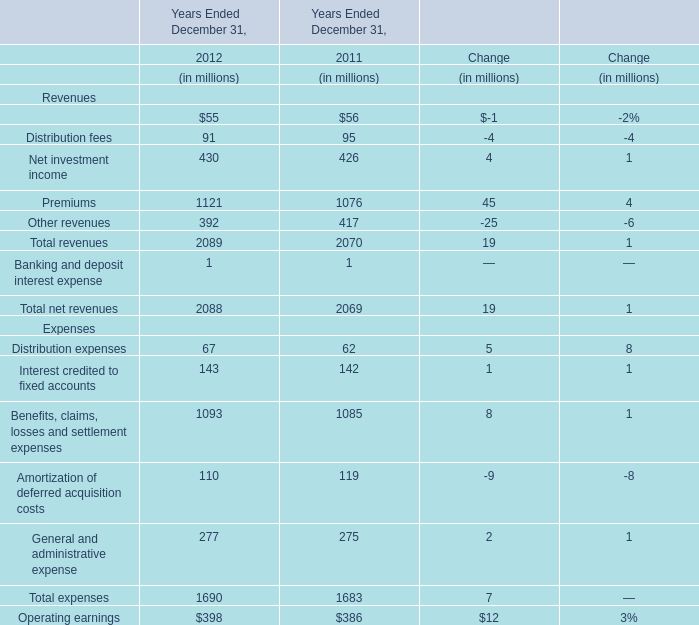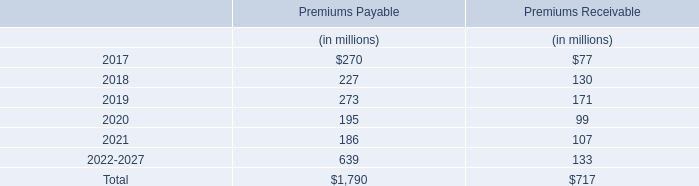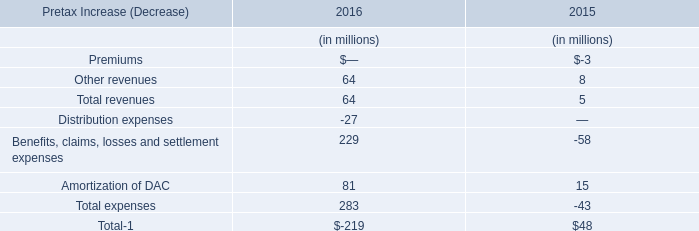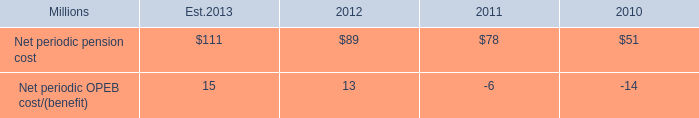What will total net revenues be like in 2013 if it continues to grow at the same rate as it did in 2012? (in million) 
Computations: ((((2088 - 2069) / 2069) + 1) * 2088)
Answer: 2107.17448. 